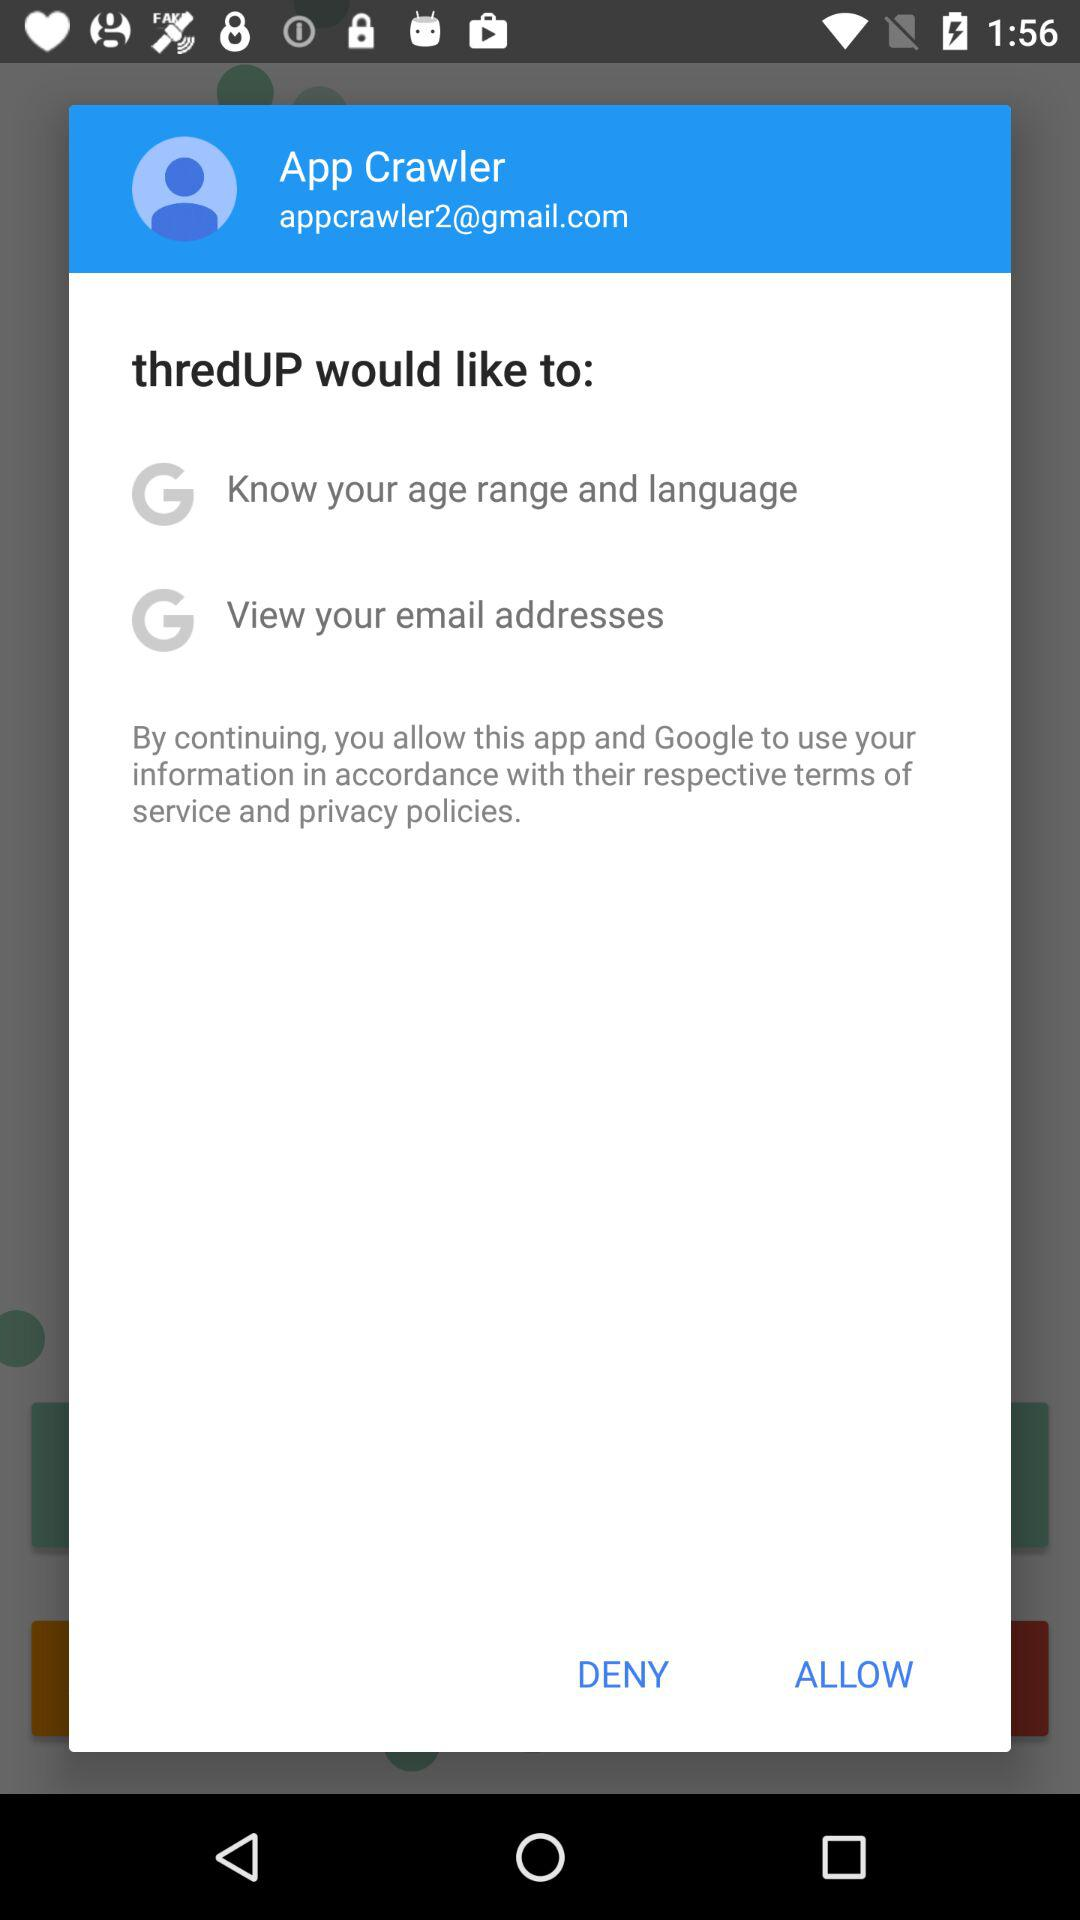How many permissions are requested by thredUP?
Answer the question using a single word or phrase. 2 